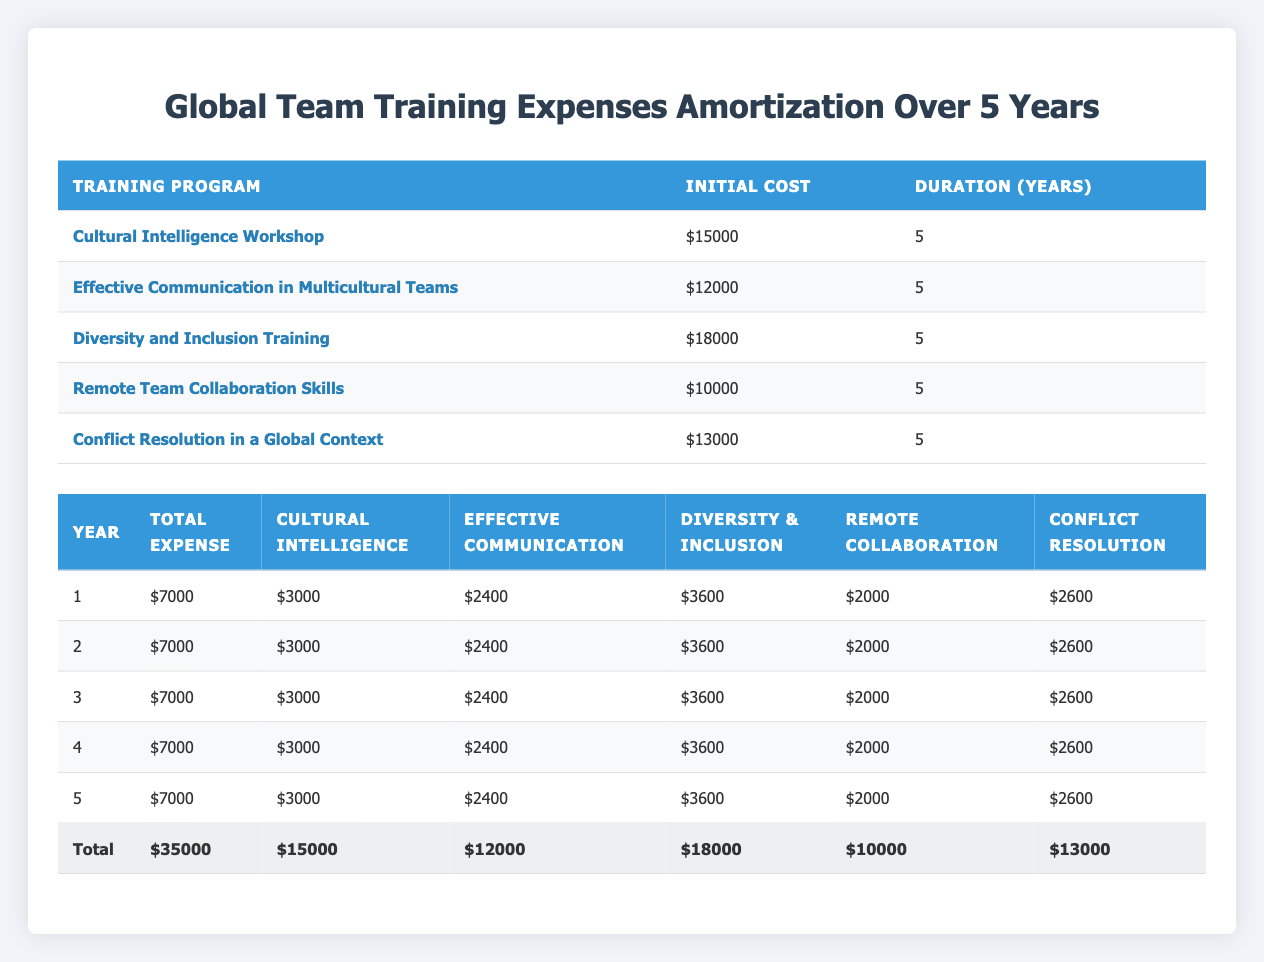What is the total expense for the fifth year? The total expense listed for the fifth year in the table is $7000.
Answer: 7000 What is the initial cost of the "Diversity and Inclusion Training"? Referring to the first table, the initial cost for the Diversity and Inclusion Training program is $18000.
Answer: 18000 Did the "Effective Communication in Multicultural Teams" program have the highest initial cost? The "Effective Communication in Multicultural Teams" program has an initial cost of $12000, which is not the highest as the "Diversity and Inclusion Training" program is $18000.
Answer: No What is the total training expense over the five years? Each year shows a total expense of $7000. So, over five years, the total would be 7000 multiplied by 5, which equals $35000.
Answer: 35000 What is the average annual expense for the "Cultural Intelligence Workshop"? The annual expense for the "Cultural Intelligence Workshop" is $3000 every year for five years, so the average annual expense is simply $3000.
Answer: 3000 What was the combined spending for "Remote Team Collaboration Skills" and "Conflict Resolution in a Global Context" over the five years? Over five years, spending for Remote Team Collaboration Skills is $2000 each year (totaling $10000) and for Conflict Resolution is $2600 each year (totaling $13000). The combined total is 10000 + 13000 = $23000.
Answer: 23000 Is the annual expense for "Diversity and Inclusion Training" the same each year? Yes, the expense remains constant at $3600 each year, as seen in the amortization schedule.
Answer: Yes What is the total cost of all training programs? The total cost of all training programs is derived by adding their initial costs: 15000 + 12000 + 18000 + 10000 + 13000 = 68000.
Answer: 68000 What amount is allocated to "Conflict Resolution in a Global Context" each year? According to the table, the amount allocated to "Conflict Resolution in a Global Context" every year is $2600.
Answer: 2600 